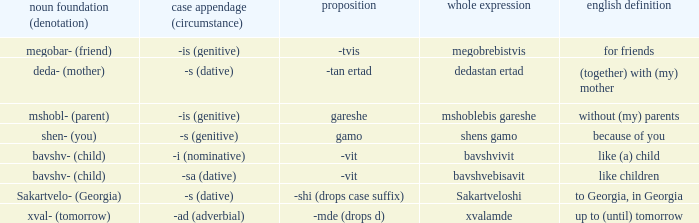What is Case Suffix (Case), when Postposition is "-mde (drops d)"? -ad (adverbial). Could you parse the entire table as a dict? {'header': ['noun foundation (denotation)', 'case appendage (circumstance)', 'proposition', 'whole expression', 'english definition'], 'rows': [['megobar- (friend)', '-is (genitive)', '-tvis', 'megobrebistvis', 'for friends'], ['deda- (mother)', '-s (dative)', '-tan ertad', 'dedastan ertad', '(together) with (my) mother'], ['mshobl- (parent)', '-is (genitive)', 'gareshe', 'mshoblebis gareshe', 'without (my) parents'], ['shen- (you)', '-s (genitive)', 'gamo', 'shens gamo', 'because of you'], ['bavshv- (child)', '-i (nominative)', '-vit', 'bavshvivit', 'like (a) child'], ['bavshv- (child)', '-sa (dative)', '-vit', 'bavshvebisavit', 'like children'], ['Sakartvelo- (Georgia)', '-s (dative)', '-shi (drops case suffix)', 'Sakartveloshi', 'to Georgia, in Georgia'], ['xval- (tomorrow)', '-ad (adverbial)', '-mde (drops d)', 'xvalamde', 'up to (until) tomorrow']]} 